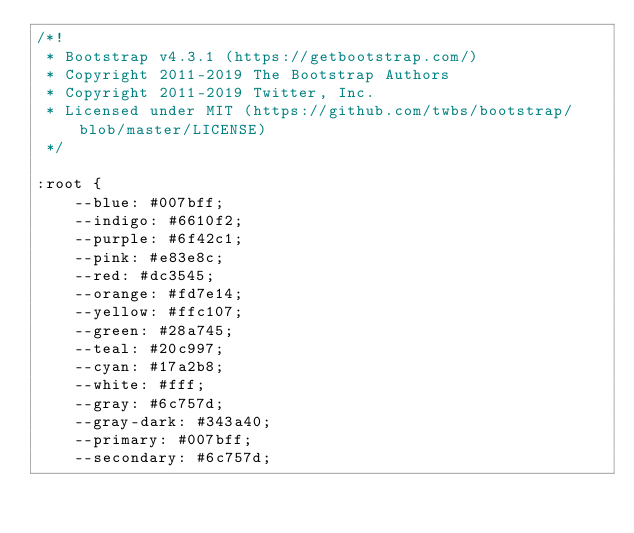Convert code to text. <code><loc_0><loc_0><loc_500><loc_500><_CSS_>/*!
 * Bootstrap v4.3.1 (https://getbootstrap.com/)
 * Copyright 2011-2019 The Bootstrap Authors
 * Copyright 2011-2019 Twitter, Inc.
 * Licensed under MIT (https://github.com/twbs/bootstrap/blob/master/LICENSE)
 */

:root {
    --blue: #007bff;
    --indigo: #6610f2;
    --purple: #6f42c1;
    --pink: #e83e8c;
    --red: #dc3545;
    --orange: #fd7e14;
    --yellow: #ffc107;
    --green: #28a745;
    --teal: #20c997;
    --cyan: #17a2b8;
    --white: #fff;
    --gray: #6c757d;
    --gray-dark: #343a40;
    --primary: #007bff;
    --secondary: #6c757d;</code> 